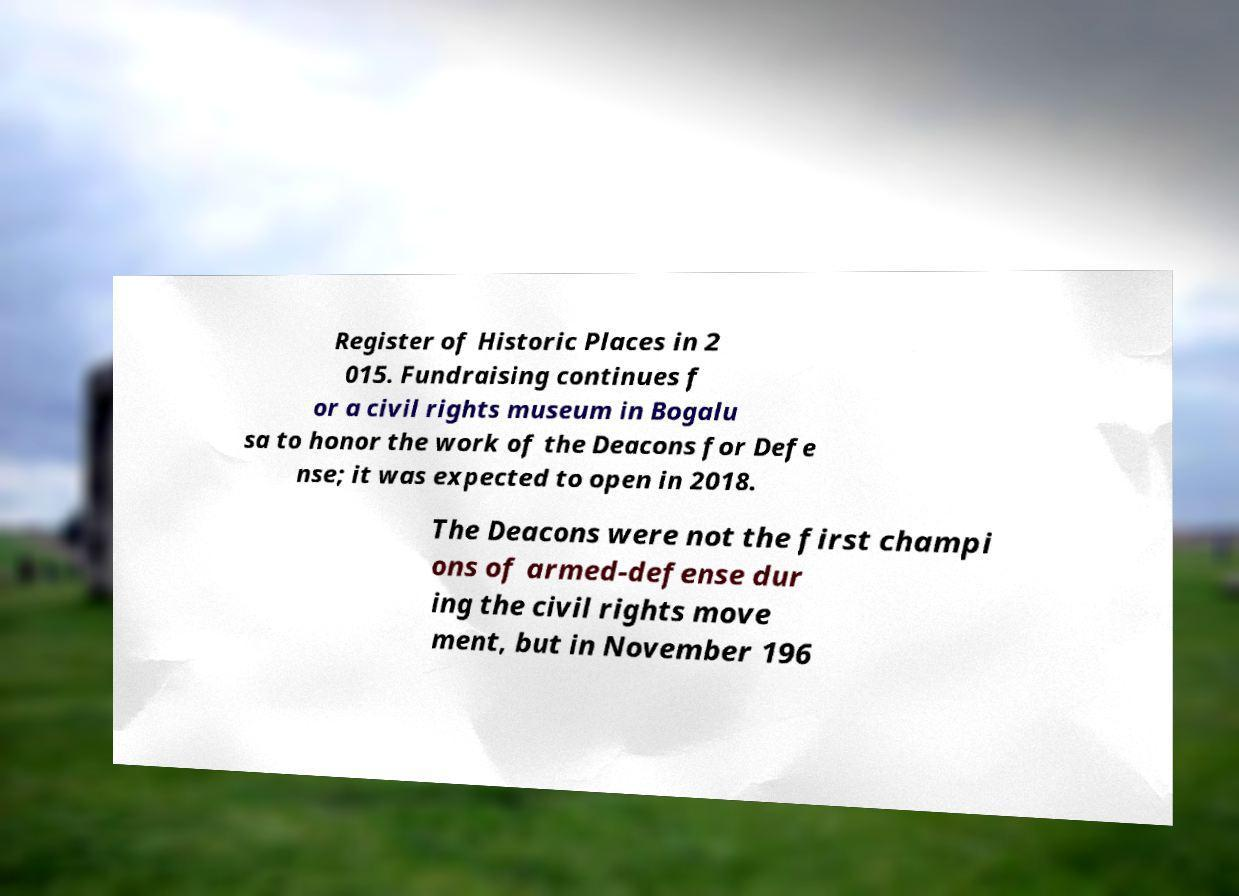There's text embedded in this image that I need extracted. Can you transcribe it verbatim? Register of Historic Places in 2 015. Fundraising continues f or a civil rights museum in Bogalu sa to honor the work of the Deacons for Defe nse; it was expected to open in 2018. The Deacons were not the first champi ons of armed-defense dur ing the civil rights move ment, but in November 196 